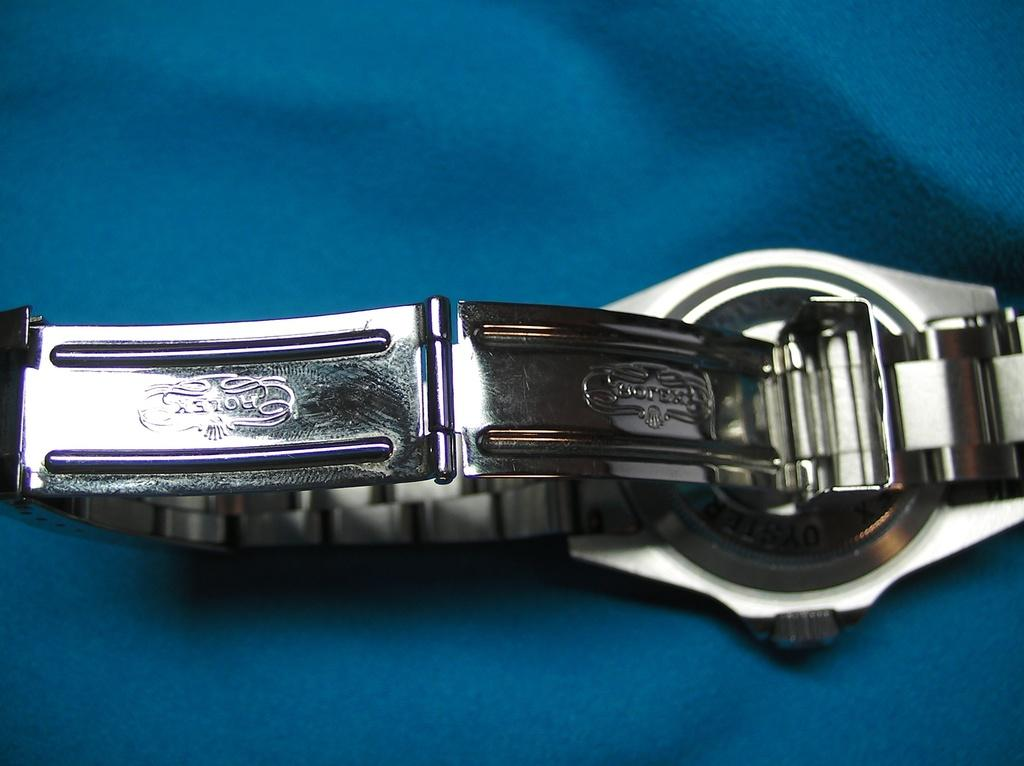Provide a one-sentence caption for the provided image. Backside of a silver rolex watch that shows the logo on the chain. 